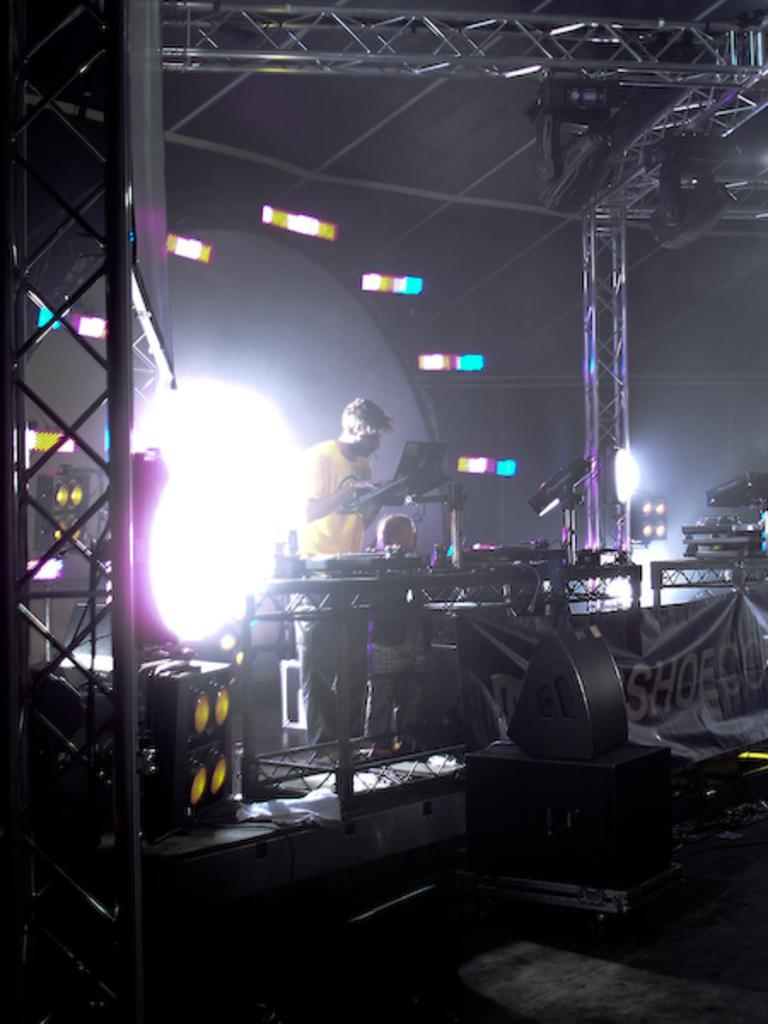What is the person in the image doing? The person is operating a musical equipment in the image. What can be seen in the image that is related to sound? There are speakers in the image. What type of lighting is present in the image? There are focus lights in the image. What material is used for the rods on the stage in the image? The rods on the stage in the image are made of metal. What is the route the person is taking to get to the stage in the image? There is no information about a route or the person's journey to the stage in the image. 